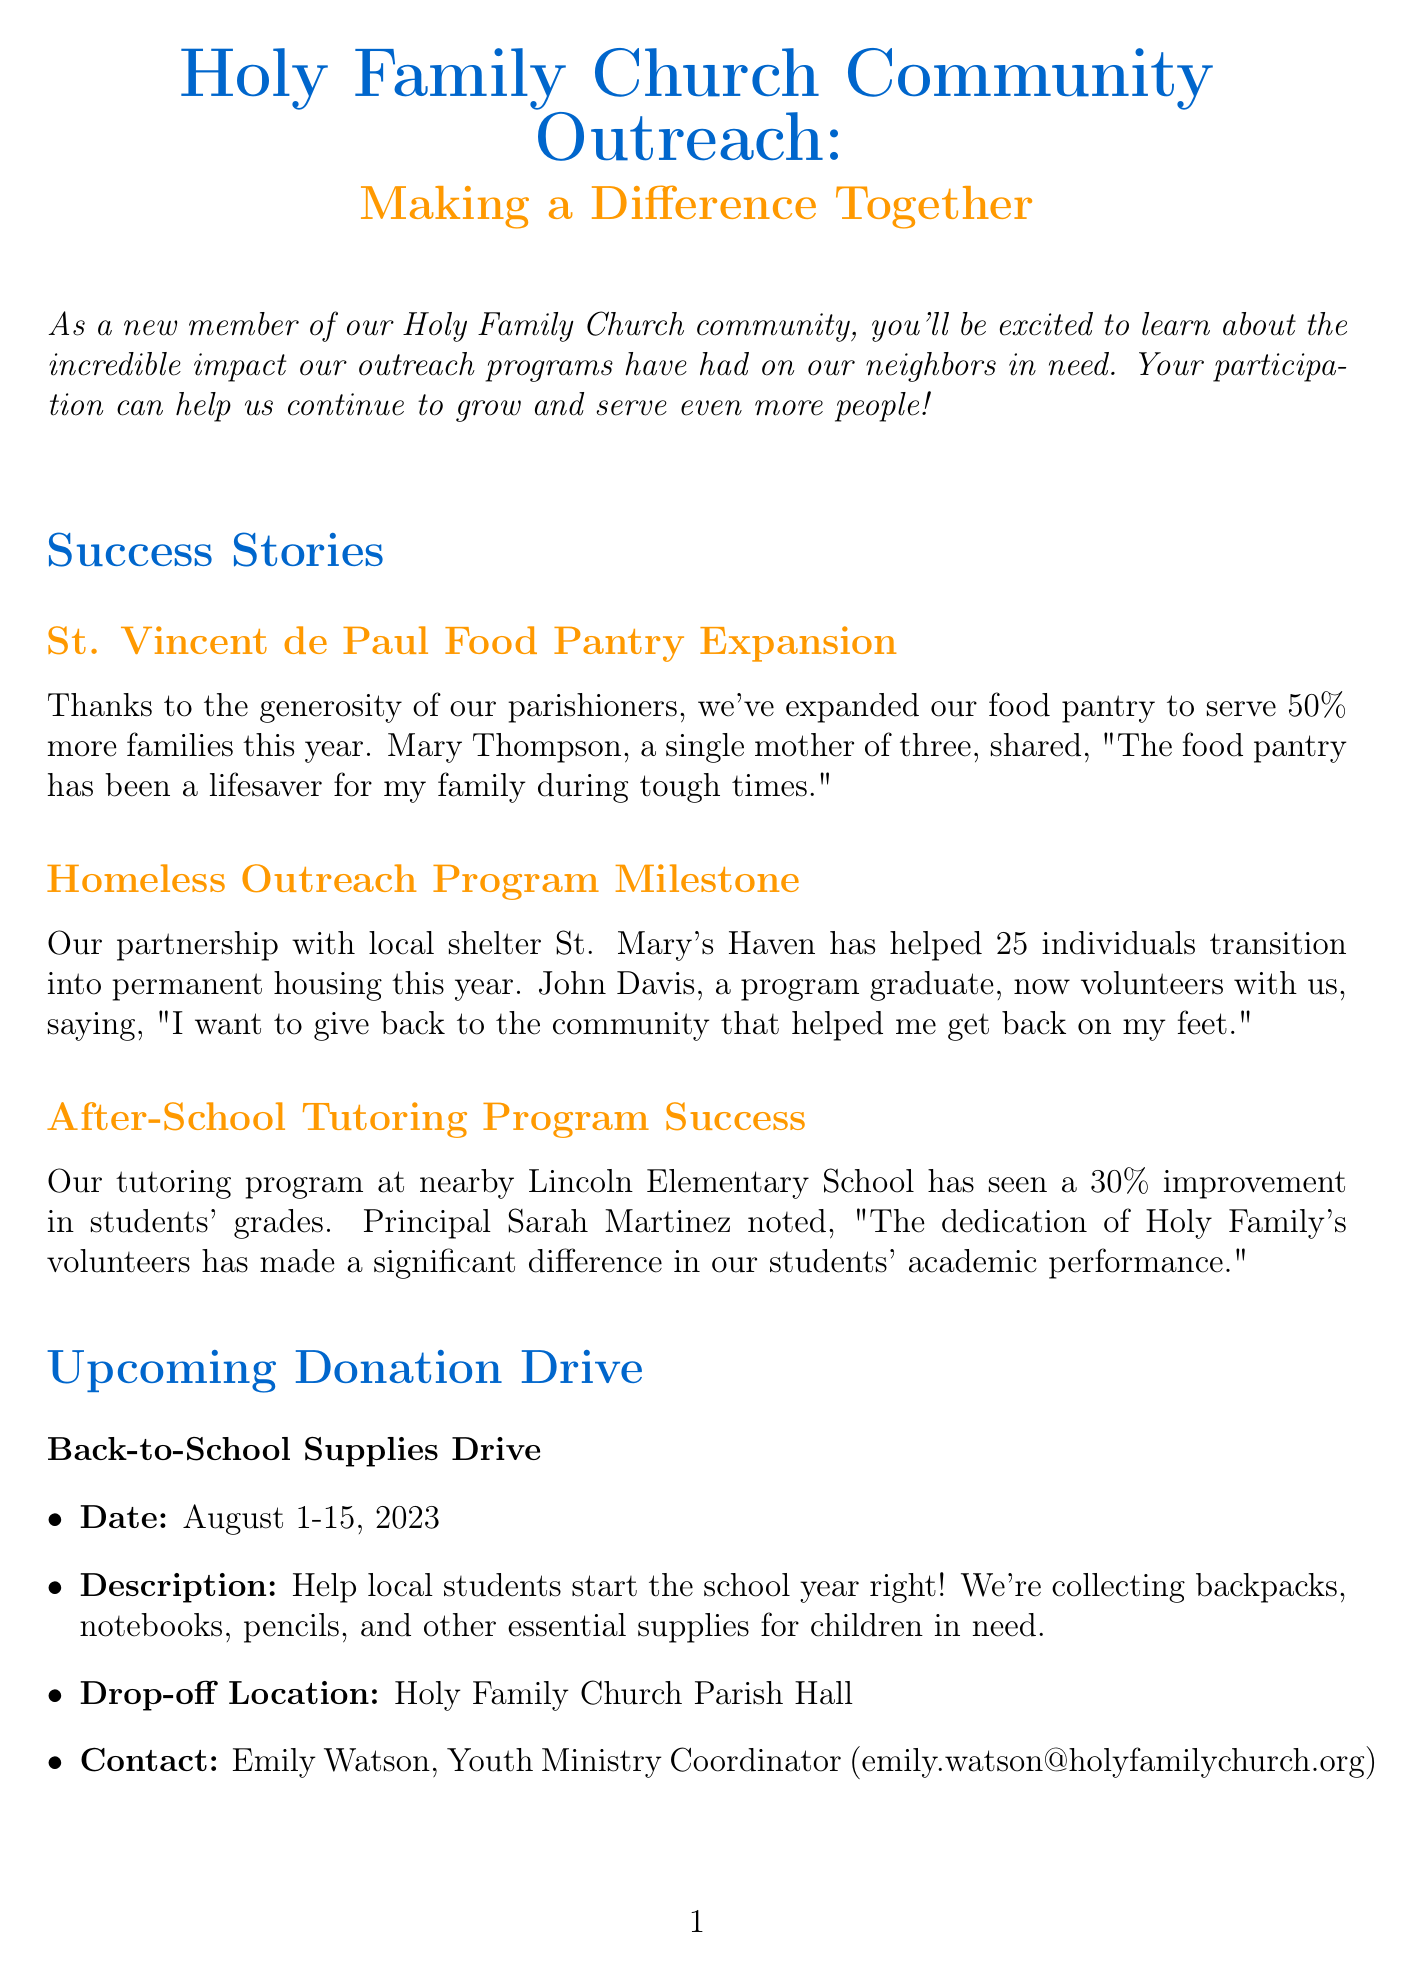What is the newsletter title? The title of the newsletter is stated at the beginning of the document.
Answer: Holy Family Church Community Outreach: Making a Difference Together Who shared a success story about the food pantry? The document mentions a specific person's testimonial regarding the food pantry.
Answer: Mary Thompson How many individuals transitioned into permanent housing through the Homeless Outreach Program? The success story details the number of individuals helped by the program.
Answer: 25 What is the date of the upcoming donation drive? The document explicitly states the duration of the donation drive.
Answer: August 1-15, 2023 What items are being collected during the Back-to-School Supplies Drive? The donation drive section lists the essential supplies needed for local students.
Answer: Backpacks, notebooks, pencils, and other essential supplies How often does the Meals on Wheels delivery occur? The document specifies the schedule for this volunteer opportunity.
Answer: Weekdays What percentage improvement was seen in the tutoring program? The success story provides specific statistical improvement regarding students' grades.
Answer: 30% How many families have been assisted this year? The community impact statistics section lists the total number of families helped.
Answer: 500 What is the contact email for the outreach coordinator? The contact information section provides details for the outreach coordinator.
Answer: outreach@holyfamilychurch.org 